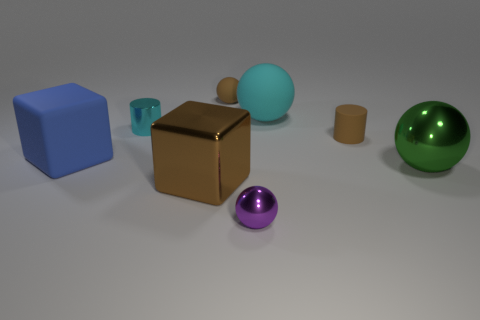Add 1 brown spheres. How many objects exist? 9 Subtract all blue spheres. Subtract all green cylinders. How many spheres are left? 4 Subtract all cylinders. How many objects are left? 6 Subtract all small matte spheres. Subtract all brown blocks. How many objects are left? 6 Add 7 small brown matte spheres. How many small brown matte spheres are left? 8 Add 3 cyan rubber things. How many cyan rubber things exist? 4 Subtract 1 brown cubes. How many objects are left? 7 